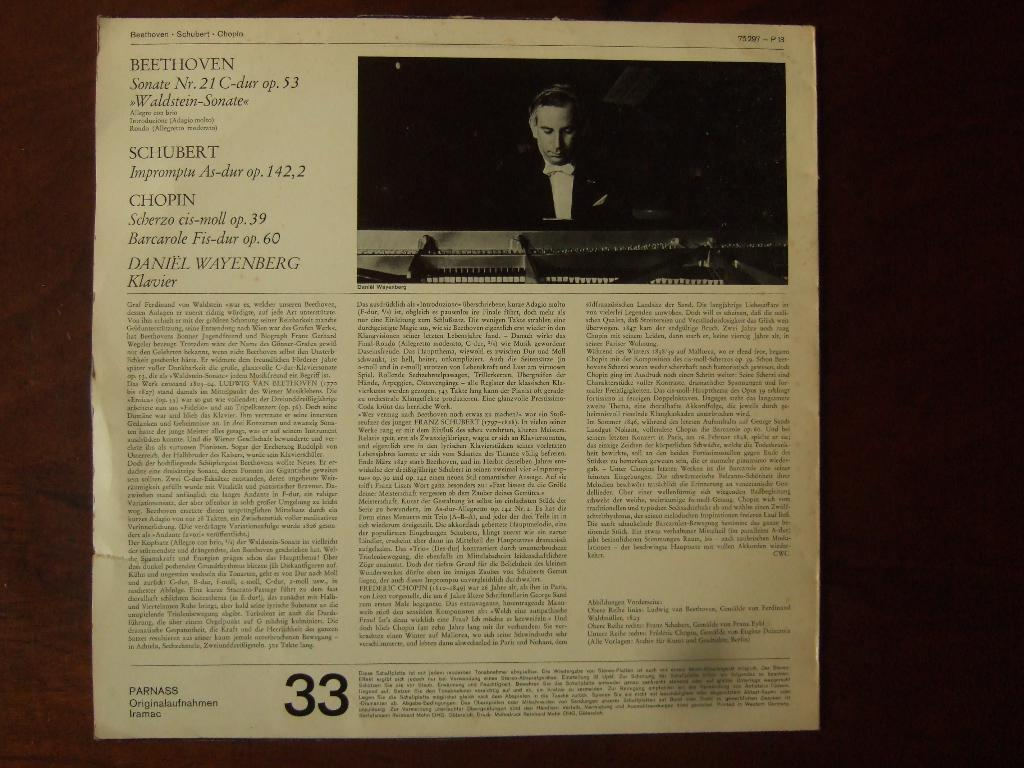What is present on the surface in the image? There is a paper on the surface in the image. Can you describe the content of the paper? The paper has an image of a person at the top right corner and text written below the image. What number is written at the bottom of the paper? The number "33" is written in bold font at the bottom of the paper. What does the person in the image say with their mouth? There is no person present in the image, only an image of a person. Additionally, the image does not show the person's mouth or any speech. 